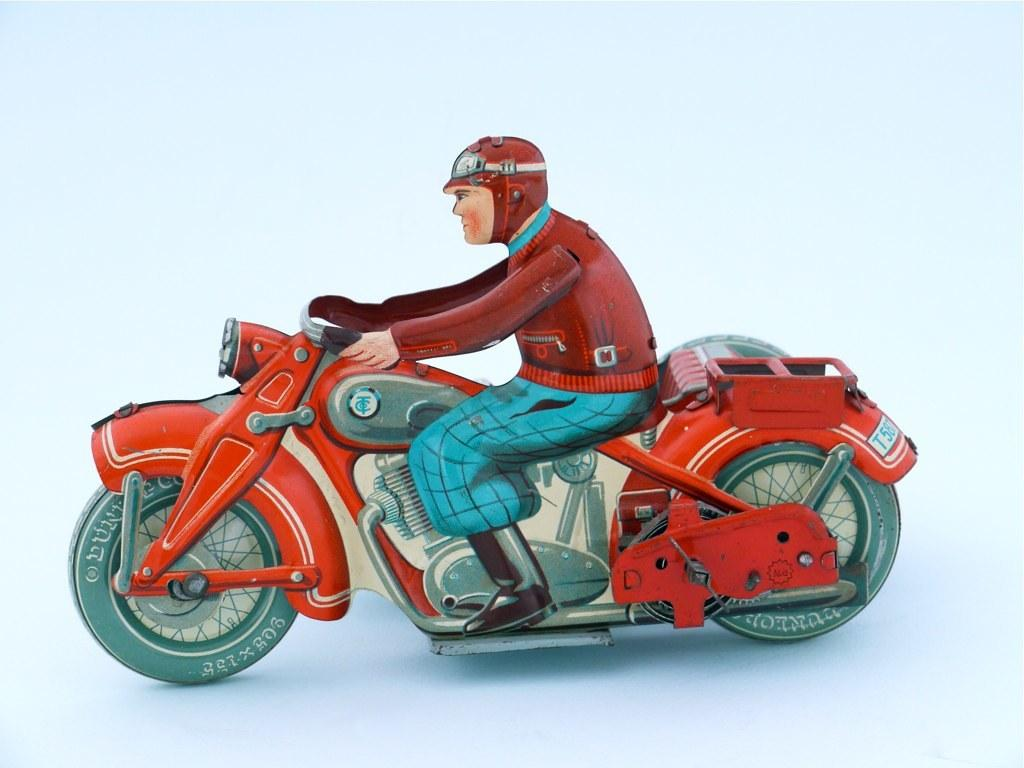What is depicted in the image? There is a drawing of a man in the image. What is the man wearing in the drawing? The man is wearing a helmet. What is the man doing in the drawing? The man is sitting on a bike. What color is the bike in the drawing? The bike is red in color. What type of pain is the man experiencing while sitting on the bike in the image? There is no indication of pain in the image; the man is simply sitting on the bike. 